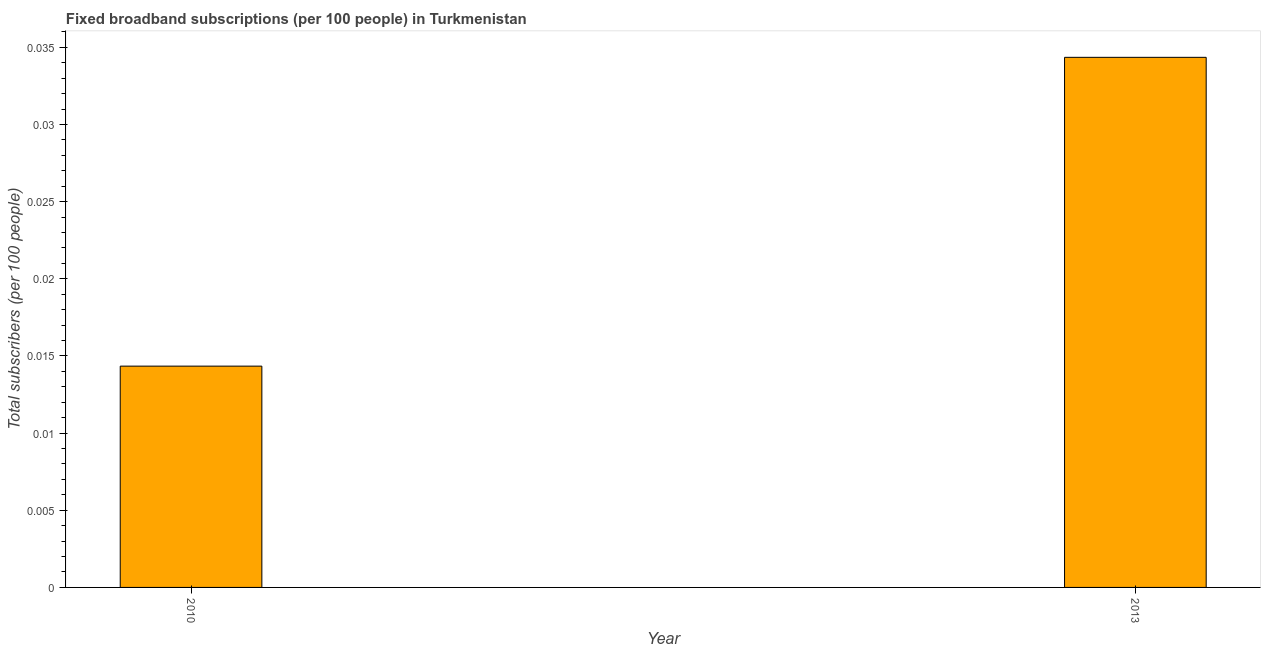Does the graph contain grids?
Your response must be concise. No. What is the title of the graph?
Keep it short and to the point. Fixed broadband subscriptions (per 100 people) in Turkmenistan. What is the label or title of the X-axis?
Your answer should be compact. Year. What is the label or title of the Y-axis?
Provide a short and direct response. Total subscribers (per 100 people). What is the total number of fixed broadband subscriptions in 2013?
Provide a short and direct response. 0.03. Across all years, what is the maximum total number of fixed broadband subscriptions?
Provide a succinct answer. 0.03. Across all years, what is the minimum total number of fixed broadband subscriptions?
Your response must be concise. 0.01. In which year was the total number of fixed broadband subscriptions minimum?
Ensure brevity in your answer.  2010. What is the sum of the total number of fixed broadband subscriptions?
Keep it short and to the point. 0.05. What is the difference between the total number of fixed broadband subscriptions in 2010 and 2013?
Provide a short and direct response. -0.02. What is the average total number of fixed broadband subscriptions per year?
Offer a very short reply. 0.02. What is the median total number of fixed broadband subscriptions?
Make the answer very short. 0.02. In how many years, is the total number of fixed broadband subscriptions greater than 0.032 ?
Your response must be concise. 1. What is the ratio of the total number of fixed broadband subscriptions in 2010 to that in 2013?
Ensure brevity in your answer.  0.42. In how many years, is the total number of fixed broadband subscriptions greater than the average total number of fixed broadband subscriptions taken over all years?
Make the answer very short. 1. How many bars are there?
Ensure brevity in your answer.  2. Are all the bars in the graph horizontal?
Offer a very short reply. No. How many years are there in the graph?
Provide a short and direct response. 2. What is the difference between two consecutive major ticks on the Y-axis?
Your answer should be very brief. 0.01. What is the Total subscribers (per 100 people) in 2010?
Keep it short and to the point. 0.01. What is the Total subscribers (per 100 people) of 2013?
Offer a very short reply. 0.03. What is the difference between the Total subscribers (per 100 people) in 2010 and 2013?
Offer a terse response. -0.02. What is the ratio of the Total subscribers (per 100 people) in 2010 to that in 2013?
Offer a terse response. 0.42. 